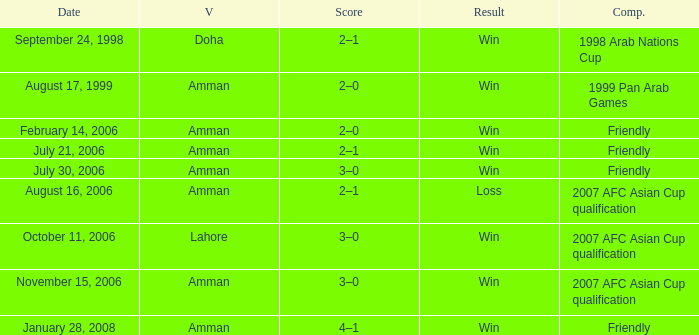What was the score of the friendly match at Amman on February 14, 2006? 2–0. 